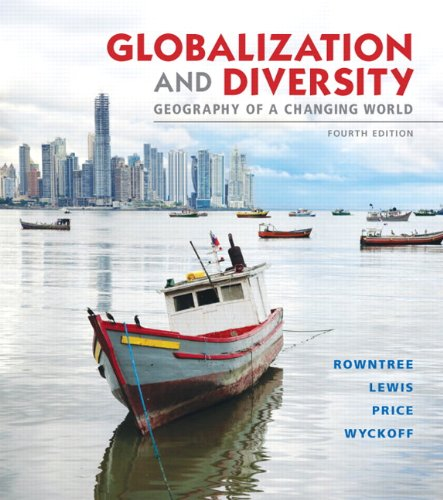Can you tell me where the photo on the cover was taken? The cover photo features a scene of colorful boats with a modern city skyline in the background, suggesting a location that blends traditional and urban elements, possibly in a coastal city in Asia or Latin America. 